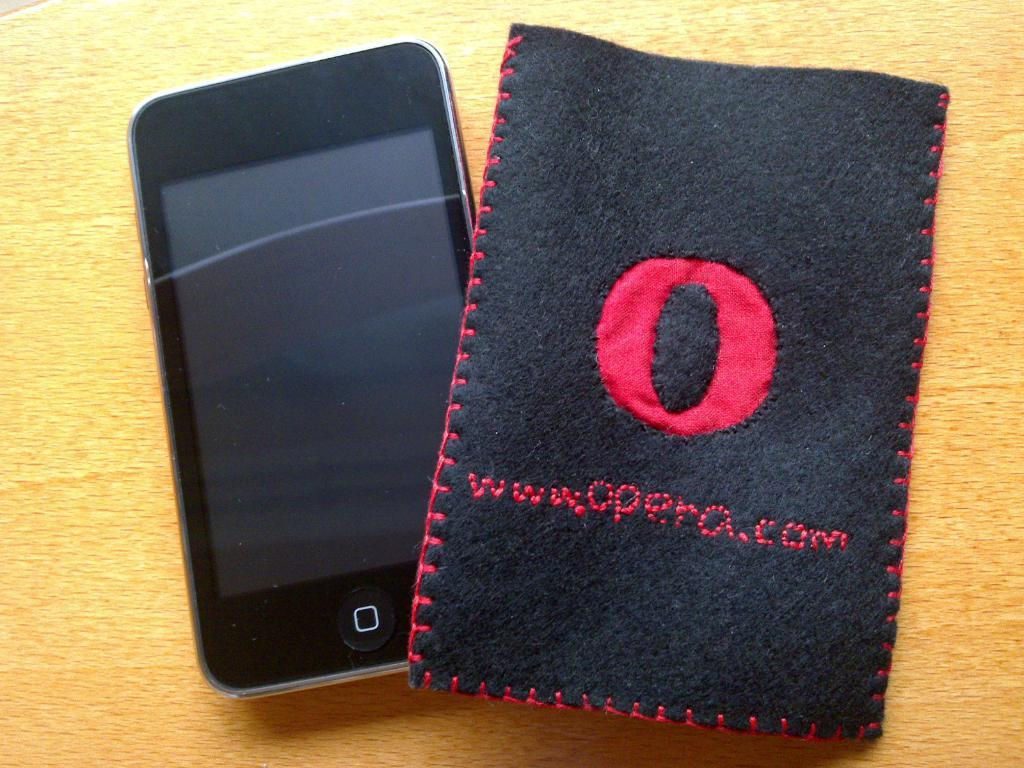<image>
Describe the image concisely. A mobile phone with a mobile phone pouch that reads "www.opera.com". 